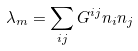<formula> <loc_0><loc_0><loc_500><loc_500>\lambda _ { m } = \sum _ { i j } G ^ { i j } n _ { i } n _ { j }</formula> 